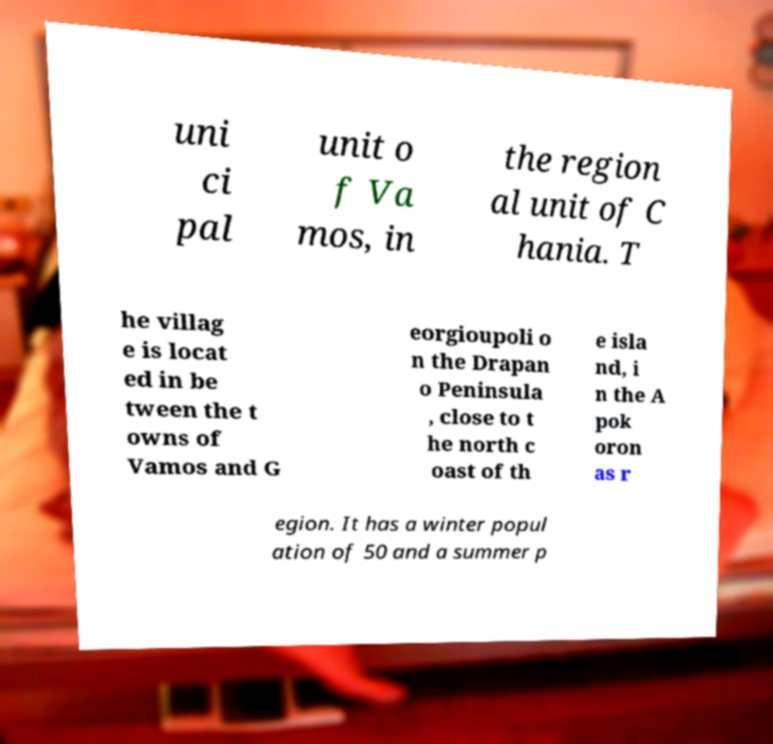Can you read and provide the text displayed in the image?This photo seems to have some interesting text. Can you extract and type it out for me? uni ci pal unit o f Va mos, in the region al unit of C hania. T he villag e is locat ed in be tween the t owns of Vamos and G eorgioupoli o n the Drapan o Peninsula , close to t he north c oast of th e isla nd, i n the A pok oron as r egion. It has a winter popul ation of 50 and a summer p 